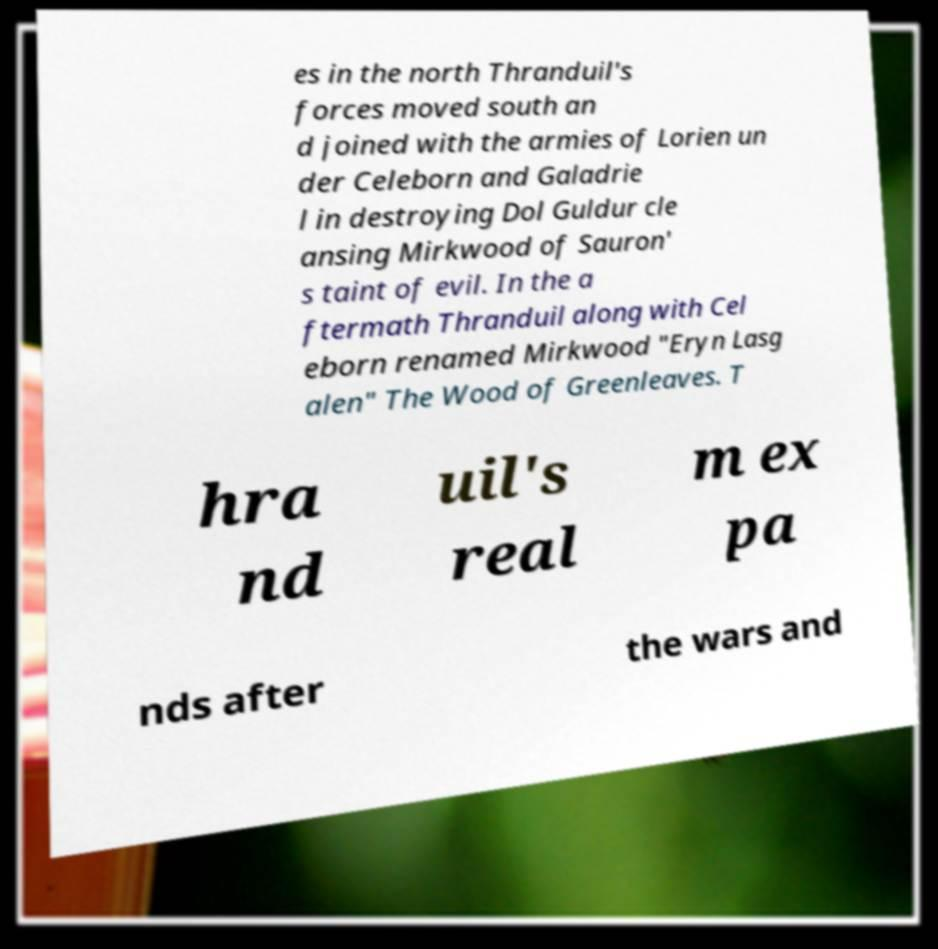Please identify and transcribe the text found in this image. es in the north Thranduil's forces moved south an d joined with the armies of Lorien un der Celeborn and Galadrie l in destroying Dol Guldur cle ansing Mirkwood of Sauron' s taint of evil. In the a ftermath Thranduil along with Cel eborn renamed Mirkwood "Eryn Lasg alen" The Wood of Greenleaves. T hra nd uil's real m ex pa nds after the wars and 